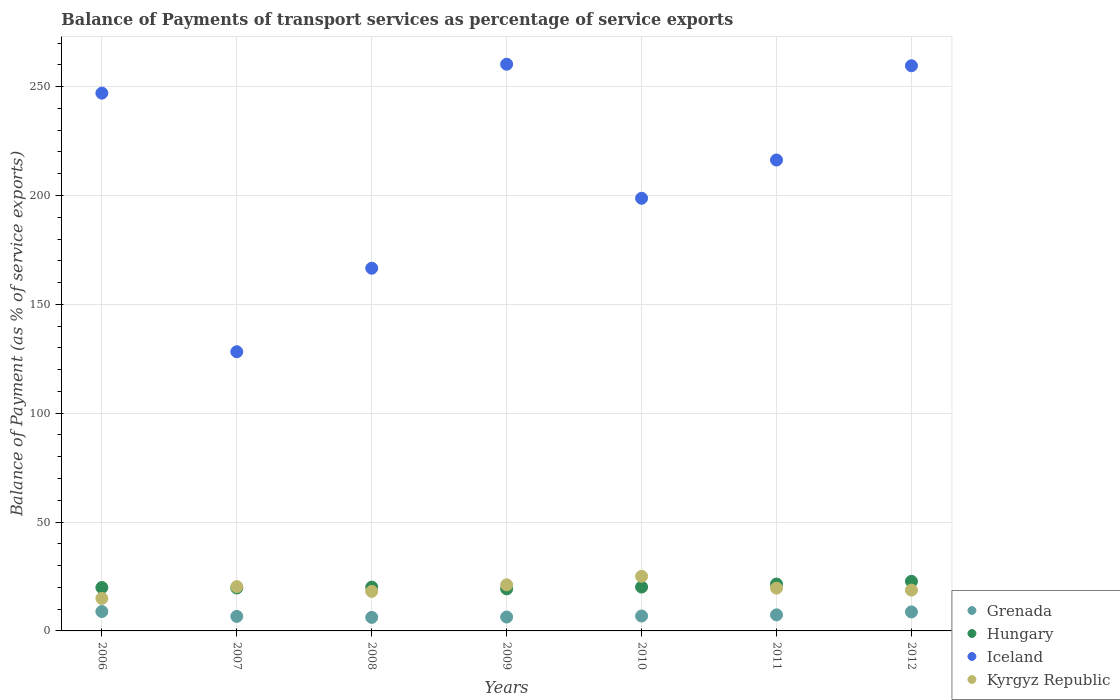How many different coloured dotlines are there?
Make the answer very short. 4. What is the balance of payments of transport services in Iceland in 2007?
Your answer should be compact. 128.23. Across all years, what is the maximum balance of payments of transport services in Hungary?
Keep it short and to the point. 22.78. Across all years, what is the minimum balance of payments of transport services in Hungary?
Offer a terse response. 19.33. In which year was the balance of payments of transport services in Hungary maximum?
Make the answer very short. 2012. In which year was the balance of payments of transport services in Hungary minimum?
Your answer should be very brief. 2009. What is the total balance of payments of transport services in Hungary in the graph?
Keep it short and to the point. 143.56. What is the difference between the balance of payments of transport services in Iceland in 2009 and that in 2012?
Keep it short and to the point. 0.7. What is the difference between the balance of payments of transport services in Grenada in 2006 and the balance of payments of transport services in Kyrgyz Republic in 2007?
Offer a terse response. -11.43. What is the average balance of payments of transport services in Hungary per year?
Give a very brief answer. 20.51. In the year 2008, what is the difference between the balance of payments of transport services in Iceland and balance of payments of transport services in Kyrgyz Republic?
Provide a short and direct response. 148.41. In how many years, is the balance of payments of transport services in Hungary greater than 40 %?
Provide a succinct answer. 0. What is the ratio of the balance of payments of transport services in Iceland in 2008 to that in 2011?
Your answer should be compact. 0.77. Is the difference between the balance of payments of transport services in Iceland in 2010 and 2012 greater than the difference between the balance of payments of transport services in Kyrgyz Republic in 2010 and 2012?
Your answer should be very brief. No. What is the difference between the highest and the second highest balance of payments of transport services in Hungary?
Provide a short and direct response. 1.24. What is the difference between the highest and the lowest balance of payments of transport services in Hungary?
Make the answer very short. 3.45. In how many years, is the balance of payments of transport services in Grenada greater than the average balance of payments of transport services in Grenada taken over all years?
Your response must be concise. 3. How many years are there in the graph?
Make the answer very short. 7. What is the difference between two consecutive major ticks on the Y-axis?
Offer a terse response. 50. Where does the legend appear in the graph?
Keep it short and to the point. Bottom right. How many legend labels are there?
Your answer should be very brief. 4. What is the title of the graph?
Give a very brief answer. Balance of Payments of transport services as percentage of service exports. What is the label or title of the Y-axis?
Your answer should be compact. Balance of Payment (as % of service exports). What is the Balance of Payment (as % of service exports) of Grenada in 2006?
Offer a terse response. 8.92. What is the Balance of Payment (as % of service exports) of Hungary in 2006?
Provide a short and direct response. 19.93. What is the Balance of Payment (as % of service exports) in Iceland in 2006?
Offer a very short reply. 247. What is the Balance of Payment (as % of service exports) of Kyrgyz Republic in 2006?
Offer a very short reply. 14.93. What is the Balance of Payment (as % of service exports) of Grenada in 2007?
Make the answer very short. 6.68. What is the Balance of Payment (as % of service exports) in Hungary in 2007?
Keep it short and to the point. 19.71. What is the Balance of Payment (as % of service exports) of Iceland in 2007?
Ensure brevity in your answer.  128.23. What is the Balance of Payment (as % of service exports) in Kyrgyz Republic in 2007?
Provide a succinct answer. 20.34. What is the Balance of Payment (as % of service exports) in Grenada in 2008?
Give a very brief answer. 6.22. What is the Balance of Payment (as % of service exports) of Hungary in 2008?
Provide a short and direct response. 20.12. What is the Balance of Payment (as % of service exports) in Iceland in 2008?
Give a very brief answer. 166.58. What is the Balance of Payment (as % of service exports) of Kyrgyz Republic in 2008?
Provide a succinct answer. 18.17. What is the Balance of Payment (as % of service exports) of Grenada in 2009?
Your answer should be compact. 6.39. What is the Balance of Payment (as % of service exports) of Hungary in 2009?
Your answer should be very brief. 19.33. What is the Balance of Payment (as % of service exports) in Iceland in 2009?
Your response must be concise. 260.27. What is the Balance of Payment (as % of service exports) in Kyrgyz Republic in 2009?
Provide a short and direct response. 21.17. What is the Balance of Payment (as % of service exports) of Grenada in 2010?
Give a very brief answer. 6.85. What is the Balance of Payment (as % of service exports) in Hungary in 2010?
Your answer should be compact. 20.15. What is the Balance of Payment (as % of service exports) of Iceland in 2010?
Your answer should be very brief. 198.71. What is the Balance of Payment (as % of service exports) in Kyrgyz Republic in 2010?
Offer a very short reply. 25.08. What is the Balance of Payment (as % of service exports) in Grenada in 2011?
Your response must be concise. 7.38. What is the Balance of Payment (as % of service exports) in Hungary in 2011?
Provide a succinct answer. 21.53. What is the Balance of Payment (as % of service exports) of Iceland in 2011?
Provide a succinct answer. 216.28. What is the Balance of Payment (as % of service exports) in Kyrgyz Republic in 2011?
Make the answer very short. 19.65. What is the Balance of Payment (as % of service exports) in Grenada in 2012?
Offer a terse response. 8.73. What is the Balance of Payment (as % of service exports) of Hungary in 2012?
Ensure brevity in your answer.  22.78. What is the Balance of Payment (as % of service exports) in Iceland in 2012?
Your response must be concise. 259.57. What is the Balance of Payment (as % of service exports) in Kyrgyz Republic in 2012?
Provide a short and direct response. 18.74. Across all years, what is the maximum Balance of Payment (as % of service exports) of Grenada?
Your answer should be compact. 8.92. Across all years, what is the maximum Balance of Payment (as % of service exports) in Hungary?
Keep it short and to the point. 22.78. Across all years, what is the maximum Balance of Payment (as % of service exports) in Iceland?
Ensure brevity in your answer.  260.27. Across all years, what is the maximum Balance of Payment (as % of service exports) in Kyrgyz Republic?
Offer a terse response. 25.08. Across all years, what is the minimum Balance of Payment (as % of service exports) of Grenada?
Your answer should be very brief. 6.22. Across all years, what is the minimum Balance of Payment (as % of service exports) in Hungary?
Your answer should be compact. 19.33. Across all years, what is the minimum Balance of Payment (as % of service exports) of Iceland?
Make the answer very short. 128.23. Across all years, what is the minimum Balance of Payment (as % of service exports) of Kyrgyz Republic?
Keep it short and to the point. 14.93. What is the total Balance of Payment (as % of service exports) in Grenada in the graph?
Ensure brevity in your answer.  51.16. What is the total Balance of Payment (as % of service exports) in Hungary in the graph?
Your response must be concise. 143.56. What is the total Balance of Payment (as % of service exports) of Iceland in the graph?
Keep it short and to the point. 1476.63. What is the total Balance of Payment (as % of service exports) of Kyrgyz Republic in the graph?
Make the answer very short. 138.1. What is the difference between the Balance of Payment (as % of service exports) of Grenada in 2006 and that in 2007?
Your response must be concise. 2.24. What is the difference between the Balance of Payment (as % of service exports) of Hungary in 2006 and that in 2007?
Ensure brevity in your answer.  0.22. What is the difference between the Balance of Payment (as % of service exports) in Iceland in 2006 and that in 2007?
Offer a very short reply. 118.77. What is the difference between the Balance of Payment (as % of service exports) of Kyrgyz Republic in 2006 and that in 2007?
Keep it short and to the point. -5.41. What is the difference between the Balance of Payment (as % of service exports) of Grenada in 2006 and that in 2008?
Your response must be concise. 2.69. What is the difference between the Balance of Payment (as % of service exports) in Hungary in 2006 and that in 2008?
Your answer should be compact. -0.19. What is the difference between the Balance of Payment (as % of service exports) in Iceland in 2006 and that in 2008?
Your answer should be compact. 80.42. What is the difference between the Balance of Payment (as % of service exports) in Kyrgyz Republic in 2006 and that in 2008?
Your answer should be very brief. -3.24. What is the difference between the Balance of Payment (as % of service exports) of Grenada in 2006 and that in 2009?
Offer a very short reply. 2.53. What is the difference between the Balance of Payment (as % of service exports) in Hungary in 2006 and that in 2009?
Your answer should be very brief. 0.61. What is the difference between the Balance of Payment (as % of service exports) of Iceland in 2006 and that in 2009?
Your answer should be compact. -13.27. What is the difference between the Balance of Payment (as % of service exports) of Kyrgyz Republic in 2006 and that in 2009?
Make the answer very short. -6.24. What is the difference between the Balance of Payment (as % of service exports) of Grenada in 2006 and that in 2010?
Ensure brevity in your answer.  2.07. What is the difference between the Balance of Payment (as % of service exports) of Hungary in 2006 and that in 2010?
Your response must be concise. -0.22. What is the difference between the Balance of Payment (as % of service exports) of Iceland in 2006 and that in 2010?
Your answer should be compact. 48.29. What is the difference between the Balance of Payment (as % of service exports) in Kyrgyz Republic in 2006 and that in 2010?
Make the answer very short. -10.15. What is the difference between the Balance of Payment (as % of service exports) in Grenada in 2006 and that in 2011?
Make the answer very short. 1.53. What is the difference between the Balance of Payment (as % of service exports) of Hungary in 2006 and that in 2011?
Ensure brevity in your answer.  -1.6. What is the difference between the Balance of Payment (as % of service exports) in Iceland in 2006 and that in 2011?
Provide a short and direct response. 30.72. What is the difference between the Balance of Payment (as % of service exports) of Kyrgyz Republic in 2006 and that in 2011?
Offer a very short reply. -4.72. What is the difference between the Balance of Payment (as % of service exports) of Grenada in 2006 and that in 2012?
Your answer should be very brief. 0.19. What is the difference between the Balance of Payment (as % of service exports) in Hungary in 2006 and that in 2012?
Your answer should be compact. -2.84. What is the difference between the Balance of Payment (as % of service exports) in Iceland in 2006 and that in 2012?
Offer a very short reply. -12.57. What is the difference between the Balance of Payment (as % of service exports) in Kyrgyz Republic in 2006 and that in 2012?
Provide a short and direct response. -3.81. What is the difference between the Balance of Payment (as % of service exports) in Grenada in 2007 and that in 2008?
Your answer should be compact. 0.46. What is the difference between the Balance of Payment (as % of service exports) in Hungary in 2007 and that in 2008?
Ensure brevity in your answer.  -0.41. What is the difference between the Balance of Payment (as % of service exports) in Iceland in 2007 and that in 2008?
Offer a very short reply. -38.35. What is the difference between the Balance of Payment (as % of service exports) in Kyrgyz Republic in 2007 and that in 2008?
Offer a terse response. 2.18. What is the difference between the Balance of Payment (as % of service exports) of Grenada in 2007 and that in 2009?
Your response must be concise. 0.29. What is the difference between the Balance of Payment (as % of service exports) in Hungary in 2007 and that in 2009?
Provide a succinct answer. 0.39. What is the difference between the Balance of Payment (as % of service exports) of Iceland in 2007 and that in 2009?
Ensure brevity in your answer.  -132.04. What is the difference between the Balance of Payment (as % of service exports) in Kyrgyz Republic in 2007 and that in 2009?
Offer a very short reply. -0.82. What is the difference between the Balance of Payment (as % of service exports) in Grenada in 2007 and that in 2010?
Offer a terse response. -0.17. What is the difference between the Balance of Payment (as % of service exports) of Hungary in 2007 and that in 2010?
Your answer should be very brief. -0.44. What is the difference between the Balance of Payment (as % of service exports) in Iceland in 2007 and that in 2010?
Ensure brevity in your answer.  -70.48. What is the difference between the Balance of Payment (as % of service exports) in Kyrgyz Republic in 2007 and that in 2010?
Your response must be concise. -4.74. What is the difference between the Balance of Payment (as % of service exports) in Grenada in 2007 and that in 2011?
Provide a succinct answer. -0.7. What is the difference between the Balance of Payment (as % of service exports) of Hungary in 2007 and that in 2011?
Offer a very short reply. -1.82. What is the difference between the Balance of Payment (as % of service exports) of Iceland in 2007 and that in 2011?
Make the answer very short. -88.05. What is the difference between the Balance of Payment (as % of service exports) of Kyrgyz Republic in 2007 and that in 2011?
Your answer should be compact. 0.69. What is the difference between the Balance of Payment (as % of service exports) of Grenada in 2007 and that in 2012?
Keep it short and to the point. -2.05. What is the difference between the Balance of Payment (as % of service exports) of Hungary in 2007 and that in 2012?
Your answer should be very brief. -3.06. What is the difference between the Balance of Payment (as % of service exports) of Iceland in 2007 and that in 2012?
Give a very brief answer. -131.34. What is the difference between the Balance of Payment (as % of service exports) of Kyrgyz Republic in 2007 and that in 2012?
Provide a short and direct response. 1.6. What is the difference between the Balance of Payment (as % of service exports) in Grenada in 2008 and that in 2009?
Your answer should be very brief. -0.17. What is the difference between the Balance of Payment (as % of service exports) of Hungary in 2008 and that in 2009?
Provide a short and direct response. 0.79. What is the difference between the Balance of Payment (as % of service exports) of Iceland in 2008 and that in 2009?
Your answer should be compact. -93.69. What is the difference between the Balance of Payment (as % of service exports) in Kyrgyz Republic in 2008 and that in 2009?
Offer a terse response. -3. What is the difference between the Balance of Payment (as % of service exports) of Grenada in 2008 and that in 2010?
Keep it short and to the point. -0.63. What is the difference between the Balance of Payment (as % of service exports) of Hungary in 2008 and that in 2010?
Provide a succinct answer. -0.03. What is the difference between the Balance of Payment (as % of service exports) in Iceland in 2008 and that in 2010?
Give a very brief answer. -32.13. What is the difference between the Balance of Payment (as % of service exports) of Kyrgyz Republic in 2008 and that in 2010?
Make the answer very short. -6.92. What is the difference between the Balance of Payment (as % of service exports) of Grenada in 2008 and that in 2011?
Provide a short and direct response. -1.16. What is the difference between the Balance of Payment (as % of service exports) in Hungary in 2008 and that in 2011?
Offer a very short reply. -1.41. What is the difference between the Balance of Payment (as % of service exports) of Iceland in 2008 and that in 2011?
Make the answer very short. -49.7. What is the difference between the Balance of Payment (as % of service exports) in Kyrgyz Republic in 2008 and that in 2011?
Provide a short and direct response. -1.48. What is the difference between the Balance of Payment (as % of service exports) in Grenada in 2008 and that in 2012?
Your answer should be very brief. -2.51. What is the difference between the Balance of Payment (as % of service exports) of Hungary in 2008 and that in 2012?
Your response must be concise. -2.66. What is the difference between the Balance of Payment (as % of service exports) of Iceland in 2008 and that in 2012?
Provide a succinct answer. -92.99. What is the difference between the Balance of Payment (as % of service exports) of Kyrgyz Republic in 2008 and that in 2012?
Give a very brief answer. -0.57. What is the difference between the Balance of Payment (as % of service exports) of Grenada in 2009 and that in 2010?
Ensure brevity in your answer.  -0.46. What is the difference between the Balance of Payment (as % of service exports) in Hungary in 2009 and that in 2010?
Provide a succinct answer. -0.83. What is the difference between the Balance of Payment (as % of service exports) of Iceland in 2009 and that in 2010?
Your answer should be compact. 61.56. What is the difference between the Balance of Payment (as % of service exports) of Kyrgyz Republic in 2009 and that in 2010?
Provide a short and direct response. -3.92. What is the difference between the Balance of Payment (as % of service exports) in Grenada in 2009 and that in 2011?
Offer a very short reply. -0.99. What is the difference between the Balance of Payment (as % of service exports) in Hungary in 2009 and that in 2011?
Your response must be concise. -2.21. What is the difference between the Balance of Payment (as % of service exports) of Iceland in 2009 and that in 2011?
Give a very brief answer. 43.99. What is the difference between the Balance of Payment (as % of service exports) in Kyrgyz Republic in 2009 and that in 2011?
Provide a short and direct response. 1.51. What is the difference between the Balance of Payment (as % of service exports) of Grenada in 2009 and that in 2012?
Keep it short and to the point. -2.34. What is the difference between the Balance of Payment (as % of service exports) of Hungary in 2009 and that in 2012?
Provide a succinct answer. -3.45. What is the difference between the Balance of Payment (as % of service exports) of Iceland in 2009 and that in 2012?
Make the answer very short. 0.7. What is the difference between the Balance of Payment (as % of service exports) in Kyrgyz Republic in 2009 and that in 2012?
Offer a very short reply. 2.43. What is the difference between the Balance of Payment (as % of service exports) of Grenada in 2010 and that in 2011?
Offer a terse response. -0.53. What is the difference between the Balance of Payment (as % of service exports) in Hungary in 2010 and that in 2011?
Make the answer very short. -1.38. What is the difference between the Balance of Payment (as % of service exports) of Iceland in 2010 and that in 2011?
Offer a terse response. -17.57. What is the difference between the Balance of Payment (as % of service exports) of Kyrgyz Republic in 2010 and that in 2011?
Make the answer very short. 5.43. What is the difference between the Balance of Payment (as % of service exports) of Grenada in 2010 and that in 2012?
Offer a very short reply. -1.88. What is the difference between the Balance of Payment (as % of service exports) in Hungary in 2010 and that in 2012?
Your answer should be very brief. -2.62. What is the difference between the Balance of Payment (as % of service exports) in Iceland in 2010 and that in 2012?
Make the answer very short. -60.86. What is the difference between the Balance of Payment (as % of service exports) in Kyrgyz Republic in 2010 and that in 2012?
Give a very brief answer. 6.34. What is the difference between the Balance of Payment (as % of service exports) of Grenada in 2011 and that in 2012?
Offer a very short reply. -1.35. What is the difference between the Balance of Payment (as % of service exports) of Hungary in 2011 and that in 2012?
Ensure brevity in your answer.  -1.24. What is the difference between the Balance of Payment (as % of service exports) in Iceland in 2011 and that in 2012?
Give a very brief answer. -43.29. What is the difference between the Balance of Payment (as % of service exports) of Kyrgyz Republic in 2011 and that in 2012?
Your answer should be very brief. 0.91. What is the difference between the Balance of Payment (as % of service exports) in Grenada in 2006 and the Balance of Payment (as % of service exports) in Hungary in 2007?
Your answer should be very brief. -10.8. What is the difference between the Balance of Payment (as % of service exports) in Grenada in 2006 and the Balance of Payment (as % of service exports) in Iceland in 2007?
Give a very brief answer. -119.31. What is the difference between the Balance of Payment (as % of service exports) of Grenada in 2006 and the Balance of Payment (as % of service exports) of Kyrgyz Republic in 2007?
Your answer should be compact. -11.43. What is the difference between the Balance of Payment (as % of service exports) in Hungary in 2006 and the Balance of Payment (as % of service exports) in Iceland in 2007?
Give a very brief answer. -108.29. What is the difference between the Balance of Payment (as % of service exports) of Hungary in 2006 and the Balance of Payment (as % of service exports) of Kyrgyz Republic in 2007?
Your answer should be compact. -0.41. What is the difference between the Balance of Payment (as % of service exports) in Iceland in 2006 and the Balance of Payment (as % of service exports) in Kyrgyz Republic in 2007?
Make the answer very short. 226.65. What is the difference between the Balance of Payment (as % of service exports) in Grenada in 2006 and the Balance of Payment (as % of service exports) in Hungary in 2008?
Your response must be concise. -11.2. What is the difference between the Balance of Payment (as % of service exports) of Grenada in 2006 and the Balance of Payment (as % of service exports) of Iceland in 2008?
Make the answer very short. -157.67. What is the difference between the Balance of Payment (as % of service exports) in Grenada in 2006 and the Balance of Payment (as % of service exports) in Kyrgyz Republic in 2008?
Offer a terse response. -9.25. What is the difference between the Balance of Payment (as % of service exports) of Hungary in 2006 and the Balance of Payment (as % of service exports) of Iceland in 2008?
Give a very brief answer. -146.65. What is the difference between the Balance of Payment (as % of service exports) in Hungary in 2006 and the Balance of Payment (as % of service exports) in Kyrgyz Republic in 2008?
Ensure brevity in your answer.  1.76. What is the difference between the Balance of Payment (as % of service exports) of Iceland in 2006 and the Balance of Payment (as % of service exports) of Kyrgyz Republic in 2008?
Make the answer very short. 228.83. What is the difference between the Balance of Payment (as % of service exports) in Grenada in 2006 and the Balance of Payment (as % of service exports) in Hungary in 2009?
Ensure brevity in your answer.  -10.41. What is the difference between the Balance of Payment (as % of service exports) of Grenada in 2006 and the Balance of Payment (as % of service exports) of Iceland in 2009?
Make the answer very short. -251.35. What is the difference between the Balance of Payment (as % of service exports) of Grenada in 2006 and the Balance of Payment (as % of service exports) of Kyrgyz Republic in 2009?
Offer a terse response. -12.25. What is the difference between the Balance of Payment (as % of service exports) in Hungary in 2006 and the Balance of Payment (as % of service exports) in Iceland in 2009?
Your answer should be very brief. -240.34. What is the difference between the Balance of Payment (as % of service exports) of Hungary in 2006 and the Balance of Payment (as % of service exports) of Kyrgyz Republic in 2009?
Give a very brief answer. -1.23. What is the difference between the Balance of Payment (as % of service exports) in Iceland in 2006 and the Balance of Payment (as % of service exports) in Kyrgyz Republic in 2009?
Offer a terse response. 225.83. What is the difference between the Balance of Payment (as % of service exports) in Grenada in 2006 and the Balance of Payment (as % of service exports) in Hungary in 2010?
Offer a terse response. -11.24. What is the difference between the Balance of Payment (as % of service exports) in Grenada in 2006 and the Balance of Payment (as % of service exports) in Iceland in 2010?
Give a very brief answer. -189.79. What is the difference between the Balance of Payment (as % of service exports) of Grenada in 2006 and the Balance of Payment (as % of service exports) of Kyrgyz Republic in 2010?
Keep it short and to the point. -16.17. What is the difference between the Balance of Payment (as % of service exports) of Hungary in 2006 and the Balance of Payment (as % of service exports) of Iceland in 2010?
Provide a short and direct response. -178.77. What is the difference between the Balance of Payment (as % of service exports) of Hungary in 2006 and the Balance of Payment (as % of service exports) of Kyrgyz Republic in 2010?
Ensure brevity in your answer.  -5.15. What is the difference between the Balance of Payment (as % of service exports) of Iceland in 2006 and the Balance of Payment (as % of service exports) of Kyrgyz Republic in 2010?
Provide a short and direct response. 221.91. What is the difference between the Balance of Payment (as % of service exports) of Grenada in 2006 and the Balance of Payment (as % of service exports) of Hungary in 2011?
Offer a very short reply. -12.62. What is the difference between the Balance of Payment (as % of service exports) of Grenada in 2006 and the Balance of Payment (as % of service exports) of Iceland in 2011?
Your answer should be very brief. -207.37. What is the difference between the Balance of Payment (as % of service exports) of Grenada in 2006 and the Balance of Payment (as % of service exports) of Kyrgyz Republic in 2011?
Keep it short and to the point. -10.74. What is the difference between the Balance of Payment (as % of service exports) in Hungary in 2006 and the Balance of Payment (as % of service exports) in Iceland in 2011?
Give a very brief answer. -196.35. What is the difference between the Balance of Payment (as % of service exports) of Hungary in 2006 and the Balance of Payment (as % of service exports) of Kyrgyz Republic in 2011?
Provide a short and direct response. 0.28. What is the difference between the Balance of Payment (as % of service exports) in Iceland in 2006 and the Balance of Payment (as % of service exports) in Kyrgyz Republic in 2011?
Your answer should be very brief. 227.34. What is the difference between the Balance of Payment (as % of service exports) of Grenada in 2006 and the Balance of Payment (as % of service exports) of Hungary in 2012?
Your answer should be compact. -13.86. What is the difference between the Balance of Payment (as % of service exports) of Grenada in 2006 and the Balance of Payment (as % of service exports) of Iceland in 2012?
Keep it short and to the point. -250.66. What is the difference between the Balance of Payment (as % of service exports) in Grenada in 2006 and the Balance of Payment (as % of service exports) in Kyrgyz Republic in 2012?
Provide a short and direct response. -9.83. What is the difference between the Balance of Payment (as % of service exports) in Hungary in 2006 and the Balance of Payment (as % of service exports) in Iceland in 2012?
Ensure brevity in your answer.  -239.64. What is the difference between the Balance of Payment (as % of service exports) of Hungary in 2006 and the Balance of Payment (as % of service exports) of Kyrgyz Republic in 2012?
Your response must be concise. 1.19. What is the difference between the Balance of Payment (as % of service exports) in Iceland in 2006 and the Balance of Payment (as % of service exports) in Kyrgyz Republic in 2012?
Keep it short and to the point. 228.25. What is the difference between the Balance of Payment (as % of service exports) in Grenada in 2007 and the Balance of Payment (as % of service exports) in Hungary in 2008?
Provide a succinct answer. -13.44. What is the difference between the Balance of Payment (as % of service exports) in Grenada in 2007 and the Balance of Payment (as % of service exports) in Iceland in 2008?
Provide a succinct answer. -159.9. What is the difference between the Balance of Payment (as % of service exports) of Grenada in 2007 and the Balance of Payment (as % of service exports) of Kyrgyz Republic in 2008?
Your answer should be very brief. -11.49. What is the difference between the Balance of Payment (as % of service exports) of Hungary in 2007 and the Balance of Payment (as % of service exports) of Iceland in 2008?
Ensure brevity in your answer.  -146.87. What is the difference between the Balance of Payment (as % of service exports) in Hungary in 2007 and the Balance of Payment (as % of service exports) in Kyrgyz Republic in 2008?
Ensure brevity in your answer.  1.54. What is the difference between the Balance of Payment (as % of service exports) in Iceland in 2007 and the Balance of Payment (as % of service exports) in Kyrgyz Republic in 2008?
Keep it short and to the point. 110.06. What is the difference between the Balance of Payment (as % of service exports) in Grenada in 2007 and the Balance of Payment (as % of service exports) in Hungary in 2009?
Your response must be concise. -12.65. What is the difference between the Balance of Payment (as % of service exports) in Grenada in 2007 and the Balance of Payment (as % of service exports) in Iceland in 2009?
Ensure brevity in your answer.  -253.59. What is the difference between the Balance of Payment (as % of service exports) in Grenada in 2007 and the Balance of Payment (as % of service exports) in Kyrgyz Republic in 2009?
Give a very brief answer. -14.49. What is the difference between the Balance of Payment (as % of service exports) of Hungary in 2007 and the Balance of Payment (as % of service exports) of Iceland in 2009?
Your answer should be very brief. -240.56. What is the difference between the Balance of Payment (as % of service exports) in Hungary in 2007 and the Balance of Payment (as % of service exports) in Kyrgyz Republic in 2009?
Give a very brief answer. -1.46. What is the difference between the Balance of Payment (as % of service exports) of Iceland in 2007 and the Balance of Payment (as % of service exports) of Kyrgyz Republic in 2009?
Your answer should be very brief. 107.06. What is the difference between the Balance of Payment (as % of service exports) in Grenada in 2007 and the Balance of Payment (as % of service exports) in Hungary in 2010?
Your response must be concise. -13.48. What is the difference between the Balance of Payment (as % of service exports) of Grenada in 2007 and the Balance of Payment (as % of service exports) of Iceland in 2010?
Give a very brief answer. -192.03. What is the difference between the Balance of Payment (as % of service exports) in Grenada in 2007 and the Balance of Payment (as % of service exports) in Kyrgyz Republic in 2010?
Your answer should be very brief. -18.41. What is the difference between the Balance of Payment (as % of service exports) of Hungary in 2007 and the Balance of Payment (as % of service exports) of Iceland in 2010?
Your answer should be very brief. -179. What is the difference between the Balance of Payment (as % of service exports) of Hungary in 2007 and the Balance of Payment (as % of service exports) of Kyrgyz Republic in 2010?
Your answer should be very brief. -5.37. What is the difference between the Balance of Payment (as % of service exports) in Iceland in 2007 and the Balance of Payment (as % of service exports) in Kyrgyz Republic in 2010?
Your response must be concise. 103.14. What is the difference between the Balance of Payment (as % of service exports) of Grenada in 2007 and the Balance of Payment (as % of service exports) of Hungary in 2011?
Provide a short and direct response. -14.86. What is the difference between the Balance of Payment (as % of service exports) of Grenada in 2007 and the Balance of Payment (as % of service exports) of Iceland in 2011?
Keep it short and to the point. -209.6. What is the difference between the Balance of Payment (as % of service exports) in Grenada in 2007 and the Balance of Payment (as % of service exports) in Kyrgyz Republic in 2011?
Offer a terse response. -12.98. What is the difference between the Balance of Payment (as % of service exports) in Hungary in 2007 and the Balance of Payment (as % of service exports) in Iceland in 2011?
Offer a terse response. -196.57. What is the difference between the Balance of Payment (as % of service exports) in Hungary in 2007 and the Balance of Payment (as % of service exports) in Kyrgyz Republic in 2011?
Your answer should be compact. 0.06. What is the difference between the Balance of Payment (as % of service exports) in Iceland in 2007 and the Balance of Payment (as % of service exports) in Kyrgyz Republic in 2011?
Your answer should be compact. 108.57. What is the difference between the Balance of Payment (as % of service exports) of Grenada in 2007 and the Balance of Payment (as % of service exports) of Hungary in 2012?
Your answer should be very brief. -16.1. What is the difference between the Balance of Payment (as % of service exports) in Grenada in 2007 and the Balance of Payment (as % of service exports) in Iceland in 2012?
Your answer should be very brief. -252.89. What is the difference between the Balance of Payment (as % of service exports) of Grenada in 2007 and the Balance of Payment (as % of service exports) of Kyrgyz Republic in 2012?
Offer a terse response. -12.07. What is the difference between the Balance of Payment (as % of service exports) in Hungary in 2007 and the Balance of Payment (as % of service exports) in Iceland in 2012?
Give a very brief answer. -239.86. What is the difference between the Balance of Payment (as % of service exports) in Hungary in 2007 and the Balance of Payment (as % of service exports) in Kyrgyz Republic in 2012?
Provide a succinct answer. 0.97. What is the difference between the Balance of Payment (as % of service exports) of Iceland in 2007 and the Balance of Payment (as % of service exports) of Kyrgyz Republic in 2012?
Provide a short and direct response. 109.48. What is the difference between the Balance of Payment (as % of service exports) of Grenada in 2008 and the Balance of Payment (as % of service exports) of Hungary in 2009?
Make the answer very short. -13.11. What is the difference between the Balance of Payment (as % of service exports) of Grenada in 2008 and the Balance of Payment (as % of service exports) of Iceland in 2009?
Provide a succinct answer. -254.05. What is the difference between the Balance of Payment (as % of service exports) of Grenada in 2008 and the Balance of Payment (as % of service exports) of Kyrgyz Republic in 2009?
Make the answer very short. -14.95. What is the difference between the Balance of Payment (as % of service exports) in Hungary in 2008 and the Balance of Payment (as % of service exports) in Iceland in 2009?
Your answer should be compact. -240.15. What is the difference between the Balance of Payment (as % of service exports) in Hungary in 2008 and the Balance of Payment (as % of service exports) in Kyrgyz Republic in 2009?
Your response must be concise. -1.05. What is the difference between the Balance of Payment (as % of service exports) of Iceland in 2008 and the Balance of Payment (as % of service exports) of Kyrgyz Republic in 2009?
Offer a very short reply. 145.41. What is the difference between the Balance of Payment (as % of service exports) in Grenada in 2008 and the Balance of Payment (as % of service exports) in Hungary in 2010?
Offer a terse response. -13.93. What is the difference between the Balance of Payment (as % of service exports) of Grenada in 2008 and the Balance of Payment (as % of service exports) of Iceland in 2010?
Provide a short and direct response. -192.49. What is the difference between the Balance of Payment (as % of service exports) of Grenada in 2008 and the Balance of Payment (as % of service exports) of Kyrgyz Republic in 2010?
Provide a short and direct response. -18.86. What is the difference between the Balance of Payment (as % of service exports) in Hungary in 2008 and the Balance of Payment (as % of service exports) in Iceland in 2010?
Keep it short and to the point. -178.59. What is the difference between the Balance of Payment (as % of service exports) in Hungary in 2008 and the Balance of Payment (as % of service exports) in Kyrgyz Republic in 2010?
Your response must be concise. -4.96. What is the difference between the Balance of Payment (as % of service exports) in Iceland in 2008 and the Balance of Payment (as % of service exports) in Kyrgyz Republic in 2010?
Provide a short and direct response. 141.5. What is the difference between the Balance of Payment (as % of service exports) of Grenada in 2008 and the Balance of Payment (as % of service exports) of Hungary in 2011?
Offer a very short reply. -15.31. What is the difference between the Balance of Payment (as % of service exports) of Grenada in 2008 and the Balance of Payment (as % of service exports) of Iceland in 2011?
Your answer should be very brief. -210.06. What is the difference between the Balance of Payment (as % of service exports) of Grenada in 2008 and the Balance of Payment (as % of service exports) of Kyrgyz Republic in 2011?
Provide a short and direct response. -13.43. What is the difference between the Balance of Payment (as % of service exports) in Hungary in 2008 and the Balance of Payment (as % of service exports) in Iceland in 2011?
Give a very brief answer. -196.16. What is the difference between the Balance of Payment (as % of service exports) in Hungary in 2008 and the Balance of Payment (as % of service exports) in Kyrgyz Republic in 2011?
Offer a terse response. 0.47. What is the difference between the Balance of Payment (as % of service exports) in Iceland in 2008 and the Balance of Payment (as % of service exports) in Kyrgyz Republic in 2011?
Ensure brevity in your answer.  146.93. What is the difference between the Balance of Payment (as % of service exports) in Grenada in 2008 and the Balance of Payment (as % of service exports) in Hungary in 2012?
Ensure brevity in your answer.  -16.56. What is the difference between the Balance of Payment (as % of service exports) of Grenada in 2008 and the Balance of Payment (as % of service exports) of Iceland in 2012?
Provide a short and direct response. -253.35. What is the difference between the Balance of Payment (as % of service exports) of Grenada in 2008 and the Balance of Payment (as % of service exports) of Kyrgyz Republic in 2012?
Offer a very short reply. -12.52. What is the difference between the Balance of Payment (as % of service exports) of Hungary in 2008 and the Balance of Payment (as % of service exports) of Iceland in 2012?
Provide a succinct answer. -239.45. What is the difference between the Balance of Payment (as % of service exports) in Hungary in 2008 and the Balance of Payment (as % of service exports) in Kyrgyz Republic in 2012?
Provide a succinct answer. 1.38. What is the difference between the Balance of Payment (as % of service exports) in Iceland in 2008 and the Balance of Payment (as % of service exports) in Kyrgyz Republic in 2012?
Keep it short and to the point. 147.84. What is the difference between the Balance of Payment (as % of service exports) in Grenada in 2009 and the Balance of Payment (as % of service exports) in Hungary in 2010?
Ensure brevity in your answer.  -13.76. What is the difference between the Balance of Payment (as % of service exports) in Grenada in 2009 and the Balance of Payment (as % of service exports) in Iceland in 2010?
Ensure brevity in your answer.  -192.32. What is the difference between the Balance of Payment (as % of service exports) in Grenada in 2009 and the Balance of Payment (as % of service exports) in Kyrgyz Republic in 2010?
Your answer should be very brief. -18.69. What is the difference between the Balance of Payment (as % of service exports) of Hungary in 2009 and the Balance of Payment (as % of service exports) of Iceland in 2010?
Your answer should be compact. -179.38. What is the difference between the Balance of Payment (as % of service exports) of Hungary in 2009 and the Balance of Payment (as % of service exports) of Kyrgyz Republic in 2010?
Offer a terse response. -5.76. What is the difference between the Balance of Payment (as % of service exports) in Iceland in 2009 and the Balance of Payment (as % of service exports) in Kyrgyz Republic in 2010?
Offer a terse response. 235.18. What is the difference between the Balance of Payment (as % of service exports) of Grenada in 2009 and the Balance of Payment (as % of service exports) of Hungary in 2011?
Offer a terse response. -15.14. What is the difference between the Balance of Payment (as % of service exports) in Grenada in 2009 and the Balance of Payment (as % of service exports) in Iceland in 2011?
Provide a short and direct response. -209.89. What is the difference between the Balance of Payment (as % of service exports) in Grenada in 2009 and the Balance of Payment (as % of service exports) in Kyrgyz Republic in 2011?
Provide a succinct answer. -13.26. What is the difference between the Balance of Payment (as % of service exports) in Hungary in 2009 and the Balance of Payment (as % of service exports) in Iceland in 2011?
Provide a short and direct response. -196.95. What is the difference between the Balance of Payment (as % of service exports) of Hungary in 2009 and the Balance of Payment (as % of service exports) of Kyrgyz Republic in 2011?
Your answer should be compact. -0.33. What is the difference between the Balance of Payment (as % of service exports) in Iceland in 2009 and the Balance of Payment (as % of service exports) in Kyrgyz Republic in 2011?
Provide a short and direct response. 240.61. What is the difference between the Balance of Payment (as % of service exports) of Grenada in 2009 and the Balance of Payment (as % of service exports) of Hungary in 2012?
Ensure brevity in your answer.  -16.39. What is the difference between the Balance of Payment (as % of service exports) in Grenada in 2009 and the Balance of Payment (as % of service exports) in Iceland in 2012?
Ensure brevity in your answer.  -253.18. What is the difference between the Balance of Payment (as % of service exports) of Grenada in 2009 and the Balance of Payment (as % of service exports) of Kyrgyz Republic in 2012?
Your response must be concise. -12.35. What is the difference between the Balance of Payment (as % of service exports) of Hungary in 2009 and the Balance of Payment (as % of service exports) of Iceland in 2012?
Keep it short and to the point. -240.24. What is the difference between the Balance of Payment (as % of service exports) of Hungary in 2009 and the Balance of Payment (as % of service exports) of Kyrgyz Republic in 2012?
Your answer should be very brief. 0.58. What is the difference between the Balance of Payment (as % of service exports) of Iceland in 2009 and the Balance of Payment (as % of service exports) of Kyrgyz Republic in 2012?
Keep it short and to the point. 241.53. What is the difference between the Balance of Payment (as % of service exports) in Grenada in 2010 and the Balance of Payment (as % of service exports) in Hungary in 2011?
Make the answer very short. -14.68. What is the difference between the Balance of Payment (as % of service exports) in Grenada in 2010 and the Balance of Payment (as % of service exports) in Iceland in 2011?
Make the answer very short. -209.43. What is the difference between the Balance of Payment (as % of service exports) of Grenada in 2010 and the Balance of Payment (as % of service exports) of Kyrgyz Republic in 2011?
Offer a terse response. -12.81. What is the difference between the Balance of Payment (as % of service exports) in Hungary in 2010 and the Balance of Payment (as % of service exports) in Iceland in 2011?
Keep it short and to the point. -196.13. What is the difference between the Balance of Payment (as % of service exports) of Hungary in 2010 and the Balance of Payment (as % of service exports) of Kyrgyz Republic in 2011?
Your answer should be compact. 0.5. What is the difference between the Balance of Payment (as % of service exports) of Iceland in 2010 and the Balance of Payment (as % of service exports) of Kyrgyz Republic in 2011?
Offer a very short reply. 179.05. What is the difference between the Balance of Payment (as % of service exports) in Grenada in 2010 and the Balance of Payment (as % of service exports) in Hungary in 2012?
Your response must be concise. -15.93. What is the difference between the Balance of Payment (as % of service exports) of Grenada in 2010 and the Balance of Payment (as % of service exports) of Iceland in 2012?
Offer a terse response. -252.72. What is the difference between the Balance of Payment (as % of service exports) in Grenada in 2010 and the Balance of Payment (as % of service exports) in Kyrgyz Republic in 2012?
Offer a terse response. -11.9. What is the difference between the Balance of Payment (as % of service exports) of Hungary in 2010 and the Balance of Payment (as % of service exports) of Iceland in 2012?
Ensure brevity in your answer.  -239.42. What is the difference between the Balance of Payment (as % of service exports) of Hungary in 2010 and the Balance of Payment (as % of service exports) of Kyrgyz Republic in 2012?
Make the answer very short. 1.41. What is the difference between the Balance of Payment (as % of service exports) of Iceland in 2010 and the Balance of Payment (as % of service exports) of Kyrgyz Republic in 2012?
Offer a very short reply. 179.96. What is the difference between the Balance of Payment (as % of service exports) in Grenada in 2011 and the Balance of Payment (as % of service exports) in Hungary in 2012?
Ensure brevity in your answer.  -15.4. What is the difference between the Balance of Payment (as % of service exports) of Grenada in 2011 and the Balance of Payment (as % of service exports) of Iceland in 2012?
Give a very brief answer. -252.19. What is the difference between the Balance of Payment (as % of service exports) of Grenada in 2011 and the Balance of Payment (as % of service exports) of Kyrgyz Republic in 2012?
Offer a terse response. -11.36. What is the difference between the Balance of Payment (as % of service exports) of Hungary in 2011 and the Balance of Payment (as % of service exports) of Iceland in 2012?
Keep it short and to the point. -238.04. What is the difference between the Balance of Payment (as % of service exports) of Hungary in 2011 and the Balance of Payment (as % of service exports) of Kyrgyz Republic in 2012?
Give a very brief answer. 2.79. What is the difference between the Balance of Payment (as % of service exports) in Iceland in 2011 and the Balance of Payment (as % of service exports) in Kyrgyz Republic in 2012?
Give a very brief answer. 197.54. What is the average Balance of Payment (as % of service exports) in Grenada per year?
Your answer should be compact. 7.31. What is the average Balance of Payment (as % of service exports) in Hungary per year?
Offer a terse response. 20.51. What is the average Balance of Payment (as % of service exports) of Iceland per year?
Keep it short and to the point. 210.95. What is the average Balance of Payment (as % of service exports) of Kyrgyz Republic per year?
Ensure brevity in your answer.  19.73. In the year 2006, what is the difference between the Balance of Payment (as % of service exports) in Grenada and Balance of Payment (as % of service exports) in Hungary?
Your response must be concise. -11.02. In the year 2006, what is the difference between the Balance of Payment (as % of service exports) in Grenada and Balance of Payment (as % of service exports) in Iceland?
Ensure brevity in your answer.  -238.08. In the year 2006, what is the difference between the Balance of Payment (as % of service exports) of Grenada and Balance of Payment (as % of service exports) of Kyrgyz Republic?
Make the answer very short. -6.02. In the year 2006, what is the difference between the Balance of Payment (as % of service exports) in Hungary and Balance of Payment (as % of service exports) in Iceland?
Offer a terse response. -227.06. In the year 2006, what is the difference between the Balance of Payment (as % of service exports) in Hungary and Balance of Payment (as % of service exports) in Kyrgyz Republic?
Keep it short and to the point. 5. In the year 2006, what is the difference between the Balance of Payment (as % of service exports) in Iceland and Balance of Payment (as % of service exports) in Kyrgyz Republic?
Your answer should be compact. 232.06. In the year 2007, what is the difference between the Balance of Payment (as % of service exports) in Grenada and Balance of Payment (as % of service exports) in Hungary?
Your answer should be very brief. -13.04. In the year 2007, what is the difference between the Balance of Payment (as % of service exports) in Grenada and Balance of Payment (as % of service exports) in Iceland?
Your response must be concise. -121.55. In the year 2007, what is the difference between the Balance of Payment (as % of service exports) in Grenada and Balance of Payment (as % of service exports) in Kyrgyz Republic?
Your response must be concise. -13.67. In the year 2007, what is the difference between the Balance of Payment (as % of service exports) in Hungary and Balance of Payment (as % of service exports) in Iceland?
Your answer should be compact. -108.51. In the year 2007, what is the difference between the Balance of Payment (as % of service exports) in Hungary and Balance of Payment (as % of service exports) in Kyrgyz Republic?
Give a very brief answer. -0.63. In the year 2007, what is the difference between the Balance of Payment (as % of service exports) of Iceland and Balance of Payment (as % of service exports) of Kyrgyz Republic?
Keep it short and to the point. 107.88. In the year 2008, what is the difference between the Balance of Payment (as % of service exports) of Grenada and Balance of Payment (as % of service exports) of Hungary?
Provide a succinct answer. -13.9. In the year 2008, what is the difference between the Balance of Payment (as % of service exports) in Grenada and Balance of Payment (as % of service exports) in Iceland?
Your answer should be very brief. -160.36. In the year 2008, what is the difference between the Balance of Payment (as % of service exports) in Grenada and Balance of Payment (as % of service exports) in Kyrgyz Republic?
Keep it short and to the point. -11.95. In the year 2008, what is the difference between the Balance of Payment (as % of service exports) in Hungary and Balance of Payment (as % of service exports) in Iceland?
Ensure brevity in your answer.  -146.46. In the year 2008, what is the difference between the Balance of Payment (as % of service exports) of Hungary and Balance of Payment (as % of service exports) of Kyrgyz Republic?
Offer a very short reply. 1.95. In the year 2008, what is the difference between the Balance of Payment (as % of service exports) of Iceland and Balance of Payment (as % of service exports) of Kyrgyz Republic?
Give a very brief answer. 148.41. In the year 2009, what is the difference between the Balance of Payment (as % of service exports) of Grenada and Balance of Payment (as % of service exports) of Hungary?
Your response must be concise. -12.94. In the year 2009, what is the difference between the Balance of Payment (as % of service exports) in Grenada and Balance of Payment (as % of service exports) in Iceland?
Keep it short and to the point. -253.88. In the year 2009, what is the difference between the Balance of Payment (as % of service exports) of Grenada and Balance of Payment (as % of service exports) of Kyrgyz Republic?
Give a very brief answer. -14.78. In the year 2009, what is the difference between the Balance of Payment (as % of service exports) of Hungary and Balance of Payment (as % of service exports) of Iceland?
Provide a succinct answer. -240.94. In the year 2009, what is the difference between the Balance of Payment (as % of service exports) of Hungary and Balance of Payment (as % of service exports) of Kyrgyz Republic?
Ensure brevity in your answer.  -1.84. In the year 2009, what is the difference between the Balance of Payment (as % of service exports) of Iceland and Balance of Payment (as % of service exports) of Kyrgyz Republic?
Give a very brief answer. 239.1. In the year 2010, what is the difference between the Balance of Payment (as % of service exports) of Grenada and Balance of Payment (as % of service exports) of Hungary?
Your answer should be compact. -13.31. In the year 2010, what is the difference between the Balance of Payment (as % of service exports) of Grenada and Balance of Payment (as % of service exports) of Iceland?
Your answer should be very brief. -191.86. In the year 2010, what is the difference between the Balance of Payment (as % of service exports) in Grenada and Balance of Payment (as % of service exports) in Kyrgyz Republic?
Make the answer very short. -18.24. In the year 2010, what is the difference between the Balance of Payment (as % of service exports) of Hungary and Balance of Payment (as % of service exports) of Iceland?
Your response must be concise. -178.55. In the year 2010, what is the difference between the Balance of Payment (as % of service exports) of Hungary and Balance of Payment (as % of service exports) of Kyrgyz Republic?
Your answer should be very brief. -4.93. In the year 2010, what is the difference between the Balance of Payment (as % of service exports) in Iceland and Balance of Payment (as % of service exports) in Kyrgyz Republic?
Your response must be concise. 173.62. In the year 2011, what is the difference between the Balance of Payment (as % of service exports) in Grenada and Balance of Payment (as % of service exports) in Hungary?
Give a very brief answer. -14.15. In the year 2011, what is the difference between the Balance of Payment (as % of service exports) in Grenada and Balance of Payment (as % of service exports) in Iceland?
Make the answer very short. -208.9. In the year 2011, what is the difference between the Balance of Payment (as % of service exports) in Grenada and Balance of Payment (as % of service exports) in Kyrgyz Republic?
Keep it short and to the point. -12.27. In the year 2011, what is the difference between the Balance of Payment (as % of service exports) in Hungary and Balance of Payment (as % of service exports) in Iceland?
Provide a succinct answer. -194.75. In the year 2011, what is the difference between the Balance of Payment (as % of service exports) of Hungary and Balance of Payment (as % of service exports) of Kyrgyz Republic?
Provide a succinct answer. 1.88. In the year 2011, what is the difference between the Balance of Payment (as % of service exports) in Iceland and Balance of Payment (as % of service exports) in Kyrgyz Republic?
Keep it short and to the point. 196.63. In the year 2012, what is the difference between the Balance of Payment (as % of service exports) in Grenada and Balance of Payment (as % of service exports) in Hungary?
Make the answer very short. -14.05. In the year 2012, what is the difference between the Balance of Payment (as % of service exports) in Grenada and Balance of Payment (as % of service exports) in Iceland?
Provide a short and direct response. -250.84. In the year 2012, what is the difference between the Balance of Payment (as % of service exports) in Grenada and Balance of Payment (as % of service exports) in Kyrgyz Republic?
Your response must be concise. -10.02. In the year 2012, what is the difference between the Balance of Payment (as % of service exports) of Hungary and Balance of Payment (as % of service exports) of Iceland?
Offer a terse response. -236.79. In the year 2012, what is the difference between the Balance of Payment (as % of service exports) in Hungary and Balance of Payment (as % of service exports) in Kyrgyz Republic?
Offer a very short reply. 4.03. In the year 2012, what is the difference between the Balance of Payment (as % of service exports) in Iceland and Balance of Payment (as % of service exports) in Kyrgyz Republic?
Provide a succinct answer. 240.83. What is the ratio of the Balance of Payment (as % of service exports) of Grenada in 2006 to that in 2007?
Keep it short and to the point. 1.34. What is the ratio of the Balance of Payment (as % of service exports) in Hungary in 2006 to that in 2007?
Make the answer very short. 1.01. What is the ratio of the Balance of Payment (as % of service exports) of Iceland in 2006 to that in 2007?
Your answer should be compact. 1.93. What is the ratio of the Balance of Payment (as % of service exports) in Kyrgyz Republic in 2006 to that in 2007?
Keep it short and to the point. 0.73. What is the ratio of the Balance of Payment (as % of service exports) of Grenada in 2006 to that in 2008?
Ensure brevity in your answer.  1.43. What is the ratio of the Balance of Payment (as % of service exports) of Hungary in 2006 to that in 2008?
Your answer should be very brief. 0.99. What is the ratio of the Balance of Payment (as % of service exports) in Iceland in 2006 to that in 2008?
Provide a succinct answer. 1.48. What is the ratio of the Balance of Payment (as % of service exports) of Kyrgyz Republic in 2006 to that in 2008?
Offer a terse response. 0.82. What is the ratio of the Balance of Payment (as % of service exports) of Grenada in 2006 to that in 2009?
Provide a short and direct response. 1.4. What is the ratio of the Balance of Payment (as % of service exports) in Hungary in 2006 to that in 2009?
Make the answer very short. 1.03. What is the ratio of the Balance of Payment (as % of service exports) in Iceland in 2006 to that in 2009?
Your answer should be compact. 0.95. What is the ratio of the Balance of Payment (as % of service exports) of Kyrgyz Republic in 2006 to that in 2009?
Provide a succinct answer. 0.71. What is the ratio of the Balance of Payment (as % of service exports) in Grenada in 2006 to that in 2010?
Make the answer very short. 1.3. What is the ratio of the Balance of Payment (as % of service exports) of Iceland in 2006 to that in 2010?
Make the answer very short. 1.24. What is the ratio of the Balance of Payment (as % of service exports) in Kyrgyz Republic in 2006 to that in 2010?
Your answer should be compact. 0.6. What is the ratio of the Balance of Payment (as % of service exports) of Grenada in 2006 to that in 2011?
Give a very brief answer. 1.21. What is the ratio of the Balance of Payment (as % of service exports) of Hungary in 2006 to that in 2011?
Provide a succinct answer. 0.93. What is the ratio of the Balance of Payment (as % of service exports) in Iceland in 2006 to that in 2011?
Ensure brevity in your answer.  1.14. What is the ratio of the Balance of Payment (as % of service exports) of Kyrgyz Republic in 2006 to that in 2011?
Provide a succinct answer. 0.76. What is the ratio of the Balance of Payment (as % of service exports) of Grenada in 2006 to that in 2012?
Your answer should be very brief. 1.02. What is the ratio of the Balance of Payment (as % of service exports) in Hungary in 2006 to that in 2012?
Ensure brevity in your answer.  0.88. What is the ratio of the Balance of Payment (as % of service exports) of Iceland in 2006 to that in 2012?
Offer a terse response. 0.95. What is the ratio of the Balance of Payment (as % of service exports) in Kyrgyz Republic in 2006 to that in 2012?
Offer a terse response. 0.8. What is the ratio of the Balance of Payment (as % of service exports) in Grenada in 2007 to that in 2008?
Offer a terse response. 1.07. What is the ratio of the Balance of Payment (as % of service exports) of Hungary in 2007 to that in 2008?
Your response must be concise. 0.98. What is the ratio of the Balance of Payment (as % of service exports) of Iceland in 2007 to that in 2008?
Ensure brevity in your answer.  0.77. What is the ratio of the Balance of Payment (as % of service exports) of Kyrgyz Republic in 2007 to that in 2008?
Keep it short and to the point. 1.12. What is the ratio of the Balance of Payment (as % of service exports) in Grenada in 2007 to that in 2009?
Ensure brevity in your answer.  1.04. What is the ratio of the Balance of Payment (as % of service exports) in Hungary in 2007 to that in 2009?
Your answer should be compact. 1.02. What is the ratio of the Balance of Payment (as % of service exports) in Iceland in 2007 to that in 2009?
Your answer should be very brief. 0.49. What is the ratio of the Balance of Payment (as % of service exports) of Kyrgyz Republic in 2007 to that in 2009?
Ensure brevity in your answer.  0.96. What is the ratio of the Balance of Payment (as % of service exports) in Grenada in 2007 to that in 2010?
Offer a terse response. 0.98. What is the ratio of the Balance of Payment (as % of service exports) of Hungary in 2007 to that in 2010?
Your response must be concise. 0.98. What is the ratio of the Balance of Payment (as % of service exports) of Iceland in 2007 to that in 2010?
Keep it short and to the point. 0.65. What is the ratio of the Balance of Payment (as % of service exports) in Kyrgyz Republic in 2007 to that in 2010?
Your answer should be compact. 0.81. What is the ratio of the Balance of Payment (as % of service exports) of Grenada in 2007 to that in 2011?
Provide a succinct answer. 0.9. What is the ratio of the Balance of Payment (as % of service exports) of Hungary in 2007 to that in 2011?
Provide a short and direct response. 0.92. What is the ratio of the Balance of Payment (as % of service exports) in Iceland in 2007 to that in 2011?
Your answer should be compact. 0.59. What is the ratio of the Balance of Payment (as % of service exports) of Kyrgyz Republic in 2007 to that in 2011?
Offer a very short reply. 1.04. What is the ratio of the Balance of Payment (as % of service exports) of Grenada in 2007 to that in 2012?
Give a very brief answer. 0.77. What is the ratio of the Balance of Payment (as % of service exports) in Hungary in 2007 to that in 2012?
Make the answer very short. 0.87. What is the ratio of the Balance of Payment (as % of service exports) in Iceland in 2007 to that in 2012?
Offer a terse response. 0.49. What is the ratio of the Balance of Payment (as % of service exports) of Kyrgyz Republic in 2007 to that in 2012?
Offer a very short reply. 1.09. What is the ratio of the Balance of Payment (as % of service exports) in Grenada in 2008 to that in 2009?
Offer a very short reply. 0.97. What is the ratio of the Balance of Payment (as % of service exports) in Hungary in 2008 to that in 2009?
Offer a terse response. 1.04. What is the ratio of the Balance of Payment (as % of service exports) of Iceland in 2008 to that in 2009?
Your response must be concise. 0.64. What is the ratio of the Balance of Payment (as % of service exports) in Kyrgyz Republic in 2008 to that in 2009?
Offer a terse response. 0.86. What is the ratio of the Balance of Payment (as % of service exports) of Grenada in 2008 to that in 2010?
Offer a terse response. 0.91. What is the ratio of the Balance of Payment (as % of service exports) of Hungary in 2008 to that in 2010?
Offer a terse response. 1. What is the ratio of the Balance of Payment (as % of service exports) of Iceland in 2008 to that in 2010?
Provide a succinct answer. 0.84. What is the ratio of the Balance of Payment (as % of service exports) of Kyrgyz Republic in 2008 to that in 2010?
Provide a short and direct response. 0.72. What is the ratio of the Balance of Payment (as % of service exports) of Grenada in 2008 to that in 2011?
Provide a succinct answer. 0.84. What is the ratio of the Balance of Payment (as % of service exports) in Hungary in 2008 to that in 2011?
Offer a terse response. 0.93. What is the ratio of the Balance of Payment (as % of service exports) in Iceland in 2008 to that in 2011?
Ensure brevity in your answer.  0.77. What is the ratio of the Balance of Payment (as % of service exports) in Kyrgyz Republic in 2008 to that in 2011?
Offer a terse response. 0.92. What is the ratio of the Balance of Payment (as % of service exports) of Grenada in 2008 to that in 2012?
Ensure brevity in your answer.  0.71. What is the ratio of the Balance of Payment (as % of service exports) of Hungary in 2008 to that in 2012?
Keep it short and to the point. 0.88. What is the ratio of the Balance of Payment (as % of service exports) in Iceland in 2008 to that in 2012?
Your response must be concise. 0.64. What is the ratio of the Balance of Payment (as % of service exports) of Kyrgyz Republic in 2008 to that in 2012?
Provide a succinct answer. 0.97. What is the ratio of the Balance of Payment (as % of service exports) of Grenada in 2009 to that in 2010?
Your response must be concise. 0.93. What is the ratio of the Balance of Payment (as % of service exports) in Hungary in 2009 to that in 2010?
Your answer should be very brief. 0.96. What is the ratio of the Balance of Payment (as % of service exports) in Iceland in 2009 to that in 2010?
Give a very brief answer. 1.31. What is the ratio of the Balance of Payment (as % of service exports) in Kyrgyz Republic in 2009 to that in 2010?
Offer a very short reply. 0.84. What is the ratio of the Balance of Payment (as % of service exports) of Grenada in 2009 to that in 2011?
Your answer should be very brief. 0.87. What is the ratio of the Balance of Payment (as % of service exports) in Hungary in 2009 to that in 2011?
Your answer should be compact. 0.9. What is the ratio of the Balance of Payment (as % of service exports) of Iceland in 2009 to that in 2011?
Your answer should be very brief. 1.2. What is the ratio of the Balance of Payment (as % of service exports) in Kyrgyz Republic in 2009 to that in 2011?
Give a very brief answer. 1.08. What is the ratio of the Balance of Payment (as % of service exports) of Grenada in 2009 to that in 2012?
Give a very brief answer. 0.73. What is the ratio of the Balance of Payment (as % of service exports) of Hungary in 2009 to that in 2012?
Provide a short and direct response. 0.85. What is the ratio of the Balance of Payment (as % of service exports) of Iceland in 2009 to that in 2012?
Make the answer very short. 1. What is the ratio of the Balance of Payment (as % of service exports) of Kyrgyz Republic in 2009 to that in 2012?
Ensure brevity in your answer.  1.13. What is the ratio of the Balance of Payment (as % of service exports) in Grenada in 2010 to that in 2011?
Your answer should be very brief. 0.93. What is the ratio of the Balance of Payment (as % of service exports) of Hungary in 2010 to that in 2011?
Keep it short and to the point. 0.94. What is the ratio of the Balance of Payment (as % of service exports) in Iceland in 2010 to that in 2011?
Provide a short and direct response. 0.92. What is the ratio of the Balance of Payment (as % of service exports) of Kyrgyz Republic in 2010 to that in 2011?
Provide a short and direct response. 1.28. What is the ratio of the Balance of Payment (as % of service exports) of Grenada in 2010 to that in 2012?
Offer a very short reply. 0.78. What is the ratio of the Balance of Payment (as % of service exports) of Hungary in 2010 to that in 2012?
Offer a very short reply. 0.88. What is the ratio of the Balance of Payment (as % of service exports) in Iceland in 2010 to that in 2012?
Your answer should be very brief. 0.77. What is the ratio of the Balance of Payment (as % of service exports) in Kyrgyz Republic in 2010 to that in 2012?
Provide a short and direct response. 1.34. What is the ratio of the Balance of Payment (as % of service exports) in Grenada in 2011 to that in 2012?
Your answer should be compact. 0.85. What is the ratio of the Balance of Payment (as % of service exports) in Hungary in 2011 to that in 2012?
Your answer should be very brief. 0.95. What is the ratio of the Balance of Payment (as % of service exports) in Iceland in 2011 to that in 2012?
Make the answer very short. 0.83. What is the ratio of the Balance of Payment (as % of service exports) in Kyrgyz Republic in 2011 to that in 2012?
Provide a short and direct response. 1.05. What is the difference between the highest and the second highest Balance of Payment (as % of service exports) in Grenada?
Your answer should be very brief. 0.19. What is the difference between the highest and the second highest Balance of Payment (as % of service exports) of Hungary?
Your answer should be very brief. 1.24. What is the difference between the highest and the second highest Balance of Payment (as % of service exports) of Iceland?
Make the answer very short. 0.7. What is the difference between the highest and the second highest Balance of Payment (as % of service exports) in Kyrgyz Republic?
Provide a succinct answer. 3.92. What is the difference between the highest and the lowest Balance of Payment (as % of service exports) of Grenada?
Offer a very short reply. 2.69. What is the difference between the highest and the lowest Balance of Payment (as % of service exports) in Hungary?
Keep it short and to the point. 3.45. What is the difference between the highest and the lowest Balance of Payment (as % of service exports) of Iceland?
Offer a terse response. 132.04. What is the difference between the highest and the lowest Balance of Payment (as % of service exports) in Kyrgyz Republic?
Your response must be concise. 10.15. 